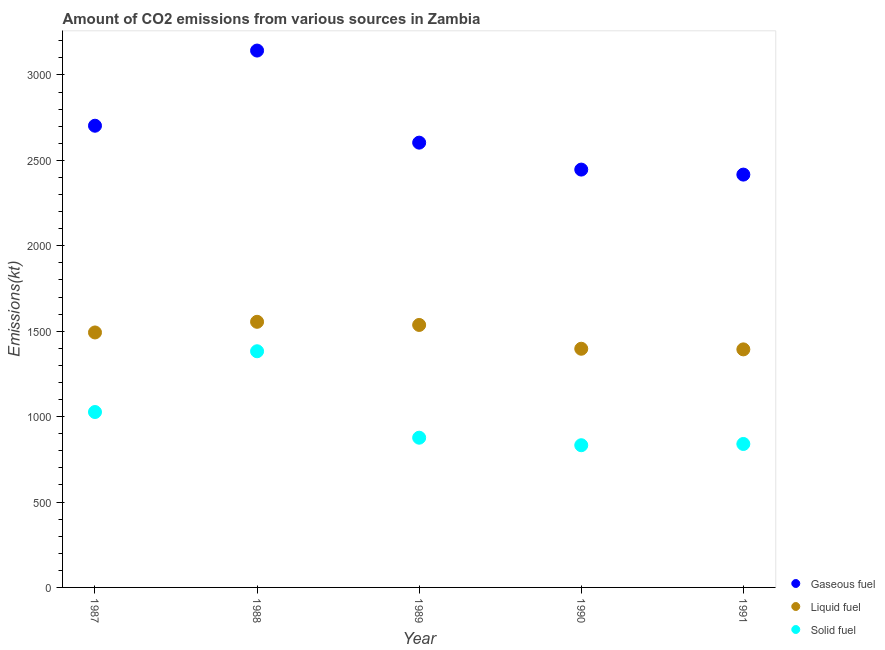Is the number of dotlines equal to the number of legend labels?
Offer a very short reply. Yes. What is the amount of co2 emissions from gaseous fuel in 1991?
Provide a short and direct response. 2416.55. Across all years, what is the maximum amount of co2 emissions from liquid fuel?
Offer a terse response. 1554.81. Across all years, what is the minimum amount of co2 emissions from gaseous fuel?
Your answer should be compact. 2416.55. What is the total amount of co2 emissions from gaseous fuel in the graph?
Provide a short and direct response. 1.33e+04. What is the difference between the amount of co2 emissions from gaseous fuel in 1987 and that in 1990?
Give a very brief answer. 256.69. What is the difference between the amount of co2 emissions from liquid fuel in 1989 and the amount of co2 emissions from gaseous fuel in 1988?
Keep it short and to the point. -1606.15. What is the average amount of co2 emissions from liquid fuel per year?
Your answer should be compact. 1474.87. In the year 1989, what is the difference between the amount of co2 emissions from solid fuel and amount of co2 emissions from gaseous fuel?
Make the answer very short. -1727.16. What is the ratio of the amount of co2 emissions from solid fuel in 1988 to that in 1989?
Give a very brief answer. 1.58. What is the difference between the highest and the second highest amount of co2 emissions from solid fuel?
Offer a terse response. 355.7. What is the difference between the highest and the lowest amount of co2 emissions from solid fuel?
Offer a terse response. 550.05. In how many years, is the amount of co2 emissions from solid fuel greater than the average amount of co2 emissions from solid fuel taken over all years?
Ensure brevity in your answer.  2. Does the amount of co2 emissions from liquid fuel monotonically increase over the years?
Provide a succinct answer. No. How many dotlines are there?
Your answer should be very brief. 3. How many years are there in the graph?
Offer a terse response. 5. Are the values on the major ticks of Y-axis written in scientific E-notation?
Provide a succinct answer. No. Does the graph contain any zero values?
Keep it short and to the point. No. Where does the legend appear in the graph?
Your answer should be very brief. Bottom right. How are the legend labels stacked?
Your answer should be very brief. Vertical. What is the title of the graph?
Provide a short and direct response. Amount of CO2 emissions from various sources in Zambia. What is the label or title of the Y-axis?
Ensure brevity in your answer.  Emissions(kt). What is the Emissions(kt) in Gaseous fuel in 1987?
Your answer should be compact. 2702.58. What is the Emissions(kt) of Liquid fuel in 1987?
Your answer should be very brief. 1492.47. What is the Emissions(kt) of Solid fuel in 1987?
Provide a succinct answer. 1026.76. What is the Emissions(kt) of Gaseous fuel in 1988?
Provide a short and direct response. 3142.62. What is the Emissions(kt) in Liquid fuel in 1988?
Keep it short and to the point. 1554.81. What is the Emissions(kt) of Solid fuel in 1988?
Offer a terse response. 1382.46. What is the Emissions(kt) in Gaseous fuel in 1989?
Ensure brevity in your answer.  2603.57. What is the Emissions(kt) of Liquid fuel in 1989?
Offer a terse response. 1536.47. What is the Emissions(kt) of Solid fuel in 1989?
Your answer should be very brief. 876.41. What is the Emissions(kt) of Gaseous fuel in 1990?
Offer a terse response. 2445.89. What is the Emissions(kt) of Liquid fuel in 1990?
Keep it short and to the point. 1397.13. What is the Emissions(kt) of Solid fuel in 1990?
Provide a succinct answer. 832.41. What is the Emissions(kt) of Gaseous fuel in 1991?
Your response must be concise. 2416.55. What is the Emissions(kt) in Liquid fuel in 1991?
Provide a short and direct response. 1393.46. What is the Emissions(kt) of Solid fuel in 1991?
Provide a short and direct response. 839.74. Across all years, what is the maximum Emissions(kt) of Gaseous fuel?
Keep it short and to the point. 3142.62. Across all years, what is the maximum Emissions(kt) of Liquid fuel?
Offer a terse response. 1554.81. Across all years, what is the maximum Emissions(kt) of Solid fuel?
Your answer should be very brief. 1382.46. Across all years, what is the minimum Emissions(kt) of Gaseous fuel?
Your response must be concise. 2416.55. Across all years, what is the minimum Emissions(kt) in Liquid fuel?
Offer a terse response. 1393.46. Across all years, what is the minimum Emissions(kt) of Solid fuel?
Make the answer very short. 832.41. What is the total Emissions(kt) in Gaseous fuel in the graph?
Provide a succinct answer. 1.33e+04. What is the total Emissions(kt) in Liquid fuel in the graph?
Your answer should be compact. 7374.34. What is the total Emissions(kt) of Solid fuel in the graph?
Your answer should be very brief. 4957.78. What is the difference between the Emissions(kt) of Gaseous fuel in 1987 and that in 1988?
Your answer should be very brief. -440.04. What is the difference between the Emissions(kt) in Liquid fuel in 1987 and that in 1988?
Make the answer very short. -62.34. What is the difference between the Emissions(kt) in Solid fuel in 1987 and that in 1988?
Your response must be concise. -355.7. What is the difference between the Emissions(kt) in Gaseous fuel in 1987 and that in 1989?
Your answer should be very brief. 99.01. What is the difference between the Emissions(kt) in Liquid fuel in 1987 and that in 1989?
Keep it short and to the point. -44. What is the difference between the Emissions(kt) in Solid fuel in 1987 and that in 1989?
Offer a very short reply. 150.35. What is the difference between the Emissions(kt) in Gaseous fuel in 1987 and that in 1990?
Make the answer very short. 256.69. What is the difference between the Emissions(kt) in Liquid fuel in 1987 and that in 1990?
Ensure brevity in your answer.  95.34. What is the difference between the Emissions(kt) in Solid fuel in 1987 and that in 1990?
Offer a very short reply. 194.35. What is the difference between the Emissions(kt) of Gaseous fuel in 1987 and that in 1991?
Your response must be concise. 286.03. What is the difference between the Emissions(kt) in Liquid fuel in 1987 and that in 1991?
Keep it short and to the point. 99.01. What is the difference between the Emissions(kt) in Solid fuel in 1987 and that in 1991?
Your response must be concise. 187.02. What is the difference between the Emissions(kt) in Gaseous fuel in 1988 and that in 1989?
Your answer should be compact. 539.05. What is the difference between the Emissions(kt) in Liquid fuel in 1988 and that in 1989?
Keep it short and to the point. 18.34. What is the difference between the Emissions(kt) in Solid fuel in 1988 and that in 1989?
Give a very brief answer. 506.05. What is the difference between the Emissions(kt) in Gaseous fuel in 1988 and that in 1990?
Your answer should be compact. 696.73. What is the difference between the Emissions(kt) of Liquid fuel in 1988 and that in 1990?
Ensure brevity in your answer.  157.68. What is the difference between the Emissions(kt) of Solid fuel in 1988 and that in 1990?
Offer a very short reply. 550.05. What is the difference between the Emissions(kt) of Gaseous fuel in 1988 and that in 1991?
Ensure brevity in your answer.  726.07. What is the difference between the Emissions(kt) in Liquid fuel in 1988 and that in 1991?
Provide a succinct answer. 161.35. What is the difference between the Emissions(kt) in Solid fuel in 1988 and that in 1991?
Give a very brief answer. 542.72. What is the difference between the Emissions(kt) in Gaseous fuel in 1989 and that in 1990?
Ensure brevity in your answer.  157.68. What is the difference between the Emissions(kt) in Liquid fuel in 1989 and that in 1990?
Your response must be concise. 139.35. What is the difference between the Emissions(kt) in Solid fuel in 1989 and that in 1990?
Keep it short and to the point. 44. What is the difference between the Emissions(kt) in Gaseous fuel in 1989 and that in 1991?
Your answer should be compact. 187.02. What is the difference between the Emissions(kt) of Liquid fuel in 1989 and that in 1991?
Keep it short and to the point. 143.01. What is the difference between the Emissions(kt) of Solid fuel in 1989 and that in 1991?
Give a very brief answer. 36.67. What is the difference between the Emissions(kt) in Gaseous fuel in 1990 and that in 1991?
Give a very brief answer. 29.34. What is the difference between the Emissions(kt) in Liquid fuel in 1990 and that in 1991?
Make the answer very short. 3.67. What is the difference between the Emissions(kt) in Solid fuel in 1990 and that in 1991?
Your response must be concise. -7.33. What is the difference between the Emissions(kt) of Gaseous fuel in 1987 and the Emissions(kt) of Liquid fuel in 1988?
Your answer should be very brief. 1147.77. What is the difference between the Emissions(kt) in Gaseous fuel in 1987 and the Emissions(kt) in Solid fuel in 1988?
Give a very brief answer. 1320.12. What is the difference between the Emissions(kt) in Liquid fuel in 1987 and the Emissions(kt) in Solid fuel in 1988?
Ensure brevity in your answer.  110.01. What is the difference between the Emissions(kt) of Gaseous fuel in 1987 and the Emissions(kt) of Liquid fuel in 1989?
Provide a short and direct response. 1166.11. What is the difference between the Emissions(kt) of Gaseous fuel in 1987 and the Emissions(kt) of Solid fuel in 1989?
Your response must be concise. 1826.17. What is the difference between the Emissions(kt) of Liquid fuel in 1987 and the Emissions(kt) of Solid fuel in 1989?
Offer a very short reply. 616.06. What is the difference between the Emissions(kt) of Gaseous fuel in 1987 and the Emissions(kt) of Liquid fuel in 1990?
Offer a very short reply. 1305.45. What is the difference between the Emissions(kt) in Gaseous fuel in 1987 and the Emissions(kt) in Solid fuel in 1990?
Give a very brief answer. 1870.17. What is the difference between the Emissions(kt) in Liquid fuel in 1987 and the Emissions(kt) in Solid fuel in 1990?
Ensure brevity in your answer.  660.06. What is the difference between the Emissions(kt) in Gaseous fuel in 1987 and the Emissions(kt) in Liquid fuel in 1991?
Provide a short and direct response. 1309.12. What is the difference between the Emissions(kt) of Gaseous fuel in 1987 and the Emissions(kt) of Solid fuel in 1991?
Give a very brief answer. 1862.84. What is the difference between the Emissions(kt) of Liquid fuel in 1987 and the Emissions(kt) of Solid fuel in 1991?
Make the answer very short. 652.73. What is the difference between the Emissions(kt) in Gaseous fuel in 1988 and the Emissions(kt) in Liquid fuel in 1989?
Ensure brevity in your answer.  1606.15. What is the difference between the Emissions(kt) in Gaseous fuel in 1988 and the Emissions(kt) in Solid fuel in 1989?
Make the answer very short. 2266.21. What is the difference between the Emissions(kt) of Liquid fuel in 1988 and the Emissions(kt) of Solid fuel in 1989?
Your answer should be very brief. 678.39. What is the difference between the Emissions(kt) in Gaseous fuel in 1988 and the Emissions(kt) in Liquid fuel in 1990?
Offer a terse response. 1745.49. What is the difference between the Emissions(kt) in Gaseous fuel in 1988 and the Emissions(kt) in Solid fuel in 1990?
Keep it short and to the point. 2310.21. What is the difference between the Emissions(kt) of Liquid fuel in 1988 and the Emissions(kt) of Solid fuel in 1990?
Your response must be concise. 722.4. What is the difference between the Emissions(kt) in Gaseous fuel in 1988 and the Emissions(kt) in Liquid fuel in 1991?
Give a very brief answer. 1749.16. What is the difference between the Emissions(kt) of Gaseous fuel in 1988 and the Emissions(kt) of Solid fuel in 1991?
Provide a succinct answer. 2302.88. What is the difference between the Emissions(kt) in Liquid fuel in 1988 and the Emissions(kt) in Solid fuel in 1991?
Provide a short and direct response. 715.07. What is the difference between the Emissions(kt) in Gaseous fuel in 1989 and the Emissions(kt) in Liquid fuel in 1990?
Make the answer very short. 1206.44. What is the difference between the Emissions(kt) in Gaseous fuel in 1989 and the Emissions(kt) in Solid fuel in 1990?
Your answer should be very brief. 1771.16. What is the difference between the Emissions(kt) in Liquid fuel in 1989 and the Emissions(kt) in Solid fuel in 1990?
Provide a succinct answer. 704.06. What is the difference between the Emissions(kt) in Gaseous fuel in 1989 and the Emissions(kt) in Liquid fuel in 1991?
Make the answer very short. 1210.11. What is the difference between the Emissions(kt) in Gaseous fuel in 1989 and the Emissions(kt) in Solid fuel in 1991?
Make the answer very short. 1763.83. What is the difference between the Emissions(kt) of Liquid fuel in 1989 and the Emissions(kt) of Solid fuel in 1991?
Offer a very short reply. 696.73. What is the difference between the Emissions(kt) in Gaseous fuel in 1990 and the Emissions(kt) in Liquid fuel in 1991?
Give a very brief answer. 1052.43. What is the difference between the Emissions(kt) of Gaseous fuel in 1990 and the Emissions(kt) of Solid fuel in 1991?
Your answer should be very brief. 1606.15. What is the difference between the Emissions(kt) in Liquid fuel in 1990 and the Emissions(kt) in Solid fuel in 1991?
Offer a very short reply. 557.38. What is the average Emissions(kt) in Gaseous fuel per year?
Ensure brevity in your answer.  2662.24. What is the average Emissions(kt) in Liquid fuel per year?
Your response must be concise. 1474.87. What is the average Emissions(kt) in Solid fuel per year?
Your response must be concise. 991.56. In the year 1987, what is the difference between the Emissions(kt) of Gaseous fuel and Emissions(kt) of Liquid fuel?
Offer a very short reply. 1210.11. In the year 1987, what is the difference between the Emissions(kt) of Gaseous fuel and Emissions(kt) of Solid fuel?
Your response must be concise. 1675.82. In the year 1987, what is the difference between the Emissions(kt) of Liquid fuel and Emissions(kt) of Solid fuel?
Your answer should be very brief. 465.71. In the year 1988, what is the difference between the Emissions(kt) of Gaseous fuel and Emissions(kt) of Liquid fuel?
Offer a terse response. 1587.81. In the year 1988, what is the difference between the Emissions(kt) in Gaseous fuel and Emissions(kt) in Solid fuel?
Make the answer very short. 1760.16. In the year 1988, what is the difference between the Emissions(kt) of Liquid fuel and Emissions(kt) of Solid fuel?
Give a very brief answer. 172.35. In the year 1989, what is the difference between the Emissions(kt) of Gaseous fuel and Emissions(kt) of Liquid fuel?
Provide a succinct answer. 1067.1. In the year 1989, what is the difference between the Emissions(kt) in Gaseous fuel and Emissions(kt) in Solid fuel?
Make the answer very short. 1727.16. In the year 1989, what is the difference between the Emissions(kt) of Liquid fuel and Emissions(kt) of Solid fuel?
Offer a terse response. 660.06. In the year 1990, what is the difference between the Emissions(kt) of Gaseous fuel and Emissions(kt) of Liquid fuel?
Your response must be concise. 1048.76. In the year 1990, what is the difference between the Emissions(kt) of Gaseous fuel and Emissions(kt) of Solid fuel?
Your answer should be very brief. 1613.48. In the year 1990, what is the difference between the Emissions(kt) in Liquid fuel and Emissions(kt) in Solid fuel?
Your answer should be compact. 564.72. In the year 1991, what is the difference between the Emissions(kt) in Gaseous fuel and Emissions(kt) in Liquid fuel?
Keep it short and to the point. 1023.09. In the year 1991, what is the difference between the Emissions(kt) in Gaseous fuel and Emissions(kt) in Solid fuel?
Provide a short and direct response. 1576.81. In the year 1991, what is the difference between the Emissions(kt) in Liquid fuel and Emissions(kt) in Solid fuel?
Provide a succinct answer. 553.72. What is the ratio of the Emissions(kt) in Gaseous fuel in 1987 to that in 1988?
Ensure brevity in your answer.  0.86. What is the ratio of the Emissions(kt) in Liquid fuel in 1987 to that in 1988?
Provide a succinct answer. 0.96. What is the ratio of the Emissions(kt) in Solid fuel in 1987 to that in 1988?
Your answer should be very brief. 0.74. What is the ratio of the Emissions(kt) in Gaseous fuel in 1987 to that in 1989?
Your response must be concise. 1.04. What is the ratio of the Emissions(kt) in Liquid fuel in 1987 to that in 1989?
Offer a terse response. 0.97. What is the ratio of the Emissions(kt) in Solid fuel in 1987 to that in 1989?
Your response must be concise. 1.17. What is the ratio of the Emissions(kt) of Gaseous fuel in 1987 to that in 1990?
Your answer should be compact. 1.1. What is the ratio of the Emissions(kt) in Liquid fuel in 1987 to that in 1990?
Ensure brevity in your answer.  1.07. What is the ratio of the Emissions(kt) of Solid fuel in 1987 to that in 1990?
Ensure brevity in your answer.  1.23. What is the ratio of the Emissions(kt) of Gaseous fuel in 1987 to that in 1991?
Your answer should be compact. 1.12. What is the ratio of the Emissions(kt) in Liquid fuel in 1987 to that in 1991?
Give a very brief answer. 1.07. What is the ratio of the Emissions(kt) of Solid fuel in 1987 to that in 1991?
Your response must be concise. 1.22. What is the ratio of the Emissions(kt) of Gaseous fuel in 1988 to that in 1989?
Ensure brevity in your answer.  1.21. What is the ratio of the Emissions(kt) of Liquid fuel in 1988 to that in 1989?
Provide a succinct answer. 1.01. What is the ratio of the Emissions(kt) of Solid fuel in 1988 to that in 1989?
Offer a terse response. 1.58. What is the ratio of the Emissions(kt) of Gaseous fuel in 1988 to that in 1990?
Make the answer very short. 1.28. What is the ratio of the Emissions(kt) of Liquid fuel in 1988 to that in 1990?
Provide a short and direct response. 1.11. What is the ratio of the Emissions(kt) in Solid fuel in 1988 to that in 1990?
Offer a very short reply. 1.66. What is the ratio of the Emissions(kt) in Gaseous fuel in 1988 to that in 1991?
Make the answer very short. 1.3. What is the ratio of the Emissions(kt) in Liquid fuel in 1988 to that in 1991?
Offer a terse response. 1.12. What is the ratio of the Emissions(kt) in Solid fuel in 1988 to that in 1991?
Provide a succinct answer. 1.65. What is the ratio of the Emissions(kt) in Gaseous fuel in 1989 to that in 1990?
Keep it short and to the point. 1.06. What is the ratio of the Emissions(kt) in Liquid fuel in 1989 to that in 1990?
Keep it short and to the point. 1.1. What is the ratio of the Emissions(kt) of Solid fuel in 1989 to that in 1990?
Provide a short and direct response. 1.05. What is the ratio of the Emissions(kt) in Gaseous fuel in 1989 to that in 1991?
Your answer should be compact. 1.08. What is the ratio of the Emissions(kt) of Liquid fuel in 1989 to that in 1991?
Provide a succinct answer. 1.1. What is the ratio of the Emissions(kt) in Solid fuel in 1989 to that in 1991?
Offer a terse response. 1.04. What is the ratio of the Emissions(kt) of Gaseous fuel in 1990 to that in 1991?
Ensure brevity in your answer.  1.01. What is the ratio of the Emissions(kt) of Liquid fuel in 1990 to that in 1991?
Your answer should be very brief. 1. What is the ratio of the Emissions(kt) in Solid fuel in 1990 to that in 1991?
Make the answer very short. 0.99. What is the difference between the highest and the second highest Emissions(kt) of Gaseous fuel?
Your answer should be very brief. 440.04. What is the difference between the highest and the second highest Emissions(kt) of Liquid fuel?
Provide a succinct answer. 18.34. What is the difference between the highest and the second highest Emissions(kt) in Solid fuel?
Your answer should be very brief. 355.7. What is the difference between the highest and the lowest Emissions(kt) in Gaseous fuel?
Provide a short and direct response. 726.07. What is the difference between the highest and the lowest Emissions(kt) in Liquid fuel?
Keep it short and to the point. 161.35. What is the difference between the highest and the lowest Emissions(kt) in Solid fuel?
Offer a very short reply. 550.05. 